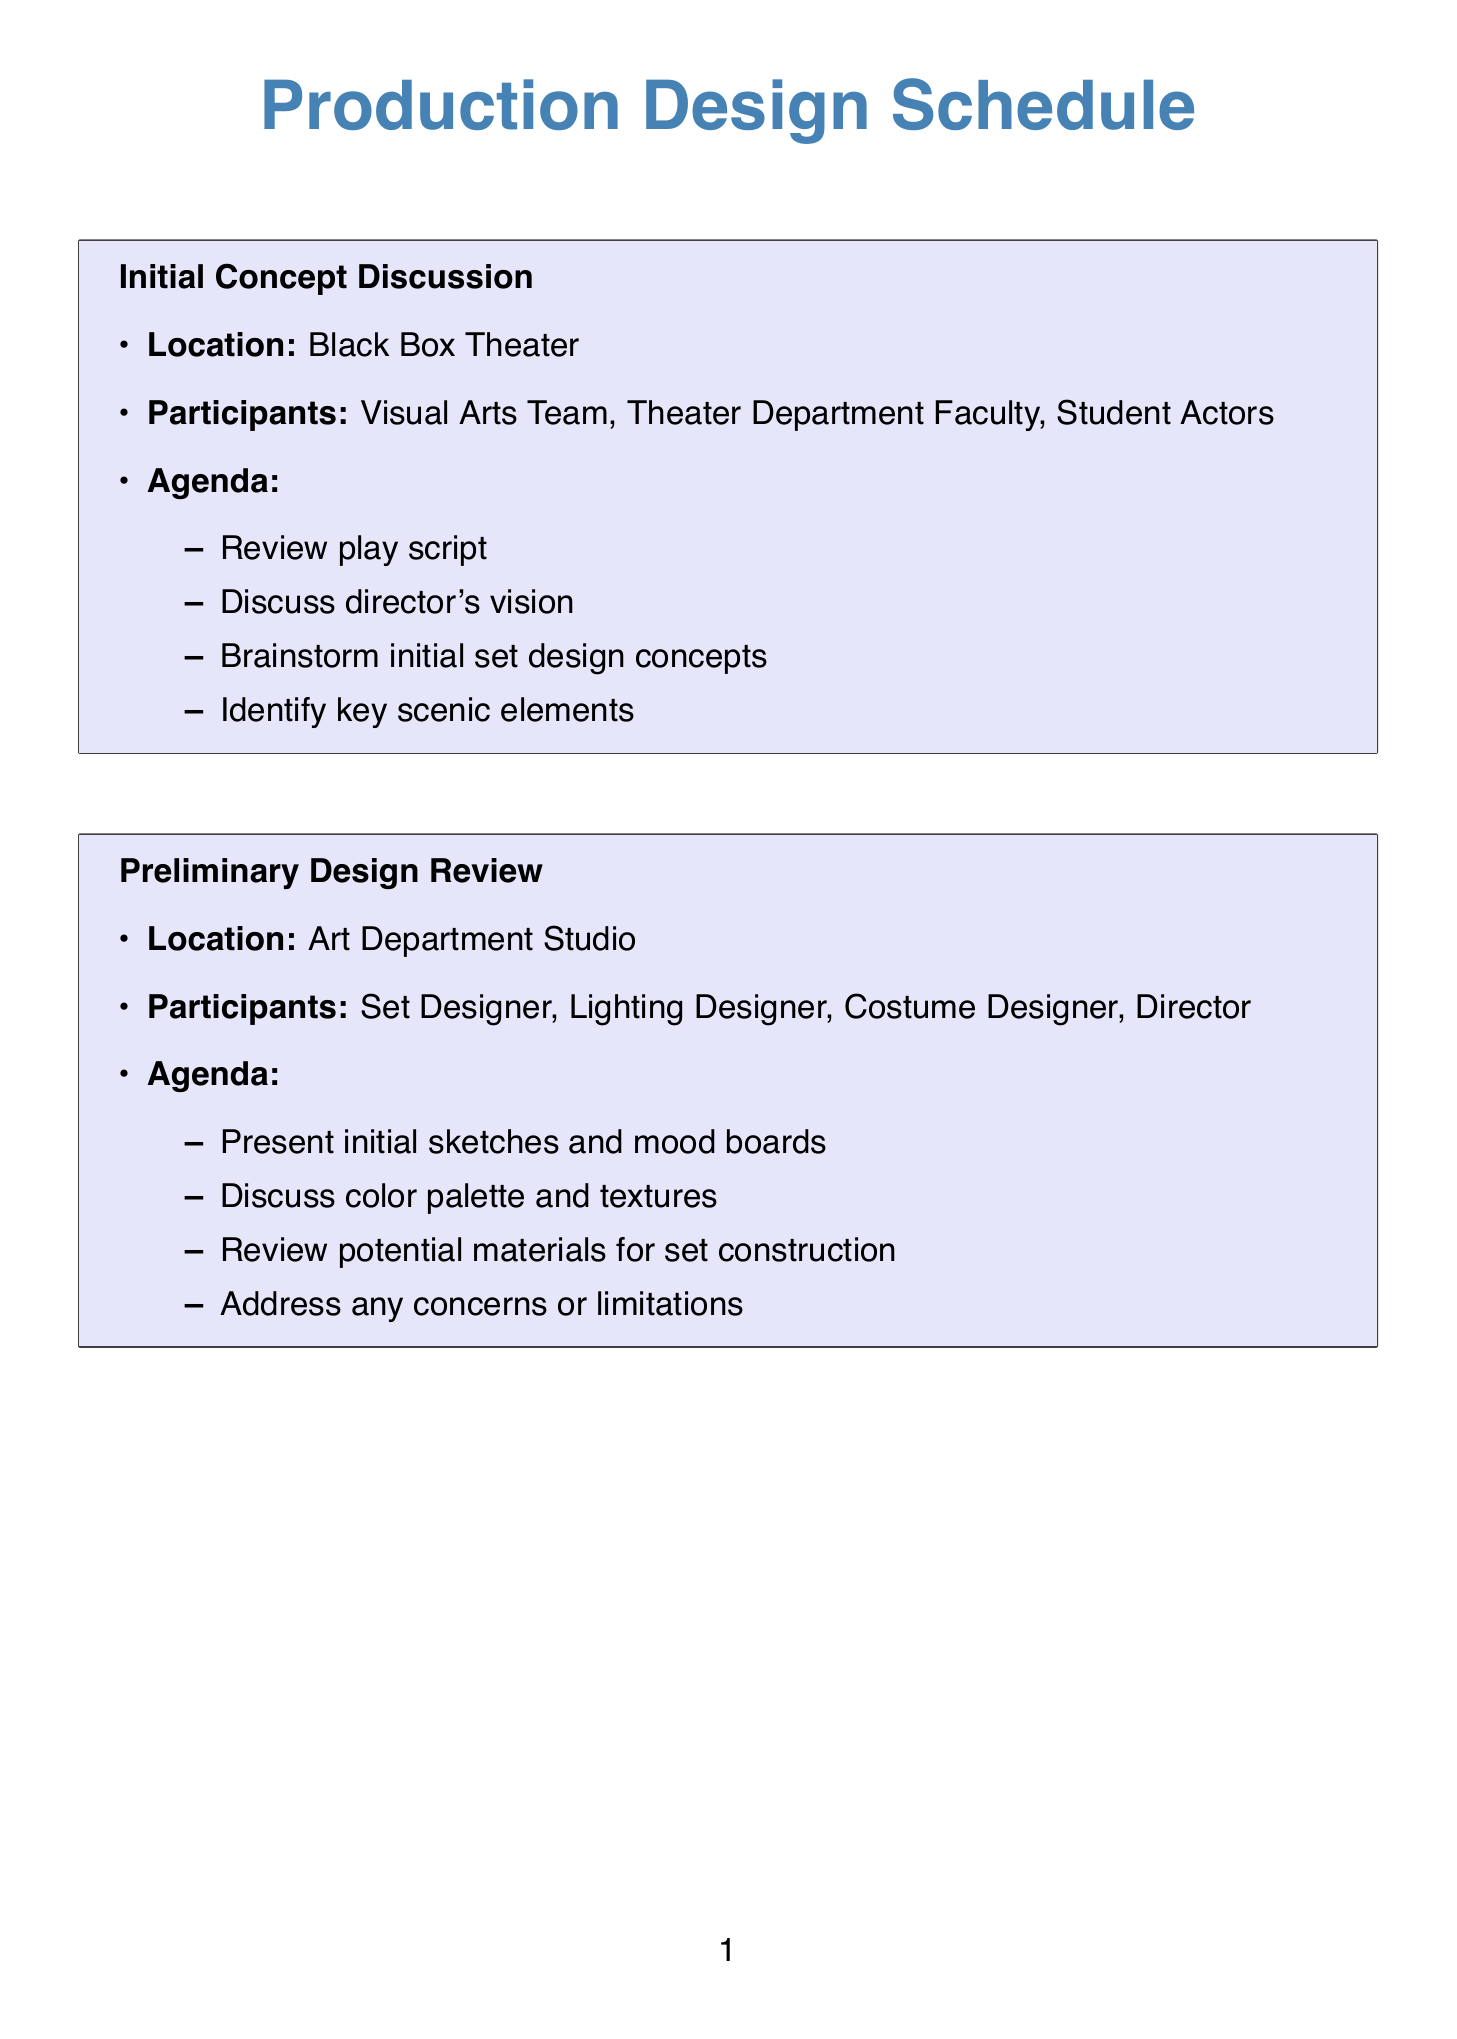What is the title of the first meeting? The title of the first meeting can be found at the beginning of the meeting's section in the document.
Answer: Initial Concept Discussion Where is the Preliminary Design Review meeting held? The location of the Preliminary Design Review meeting is specified in its section.
Answer: Art Department Studio Who participates in the Technical Feasibility Meeting? The participants in the Technical Feasibility Meeting are listed in the corresponding section.
Answer: Set Designer, Technical Director, Stage Manager, Props Master What is one of the agenda items for the Dress Rehearsal Set Review? One of the agenda items can be found in the agenda list of the Dress Rehearsal Set Review section.
Answer: Evaluate set functionality during full run-through How many design meetings are listed in the document? The total number of design meetings can be counted from the meeting titles in the document.
Answer: 7 Which department holds the Budget and Resource Allocation meeting? The department responsible for the Budget and Resource Allocation meeting is indicated in the location or participant list.
Answer: Theater Department What is the purpose of the Design Presentation to Cast? The purpose of the Design Presentation to Cast is outlined in the agenda of that meeting.
Answer: Present finalized set design concepts What is assessed during the Technical Feasibility Meeting? The assessment items for the Technical Feasibility Meeting are mentioned in its agenda section.
Answer: Evaluate set design practicality 